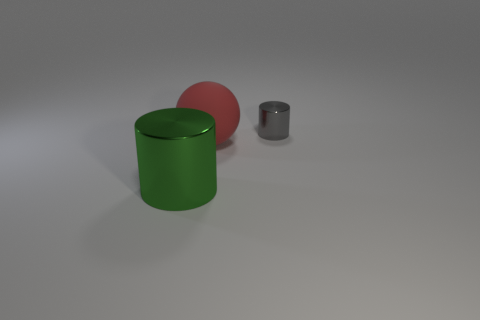Are there any other things that have the same material as the big red thing?
Provide a succinct answer. No. How many other objects are there of the same material as the small gray cylinder?
Give a very brief answer. 1. What number of things are yellow matte cubes or big spheres?
Ensure brevity in your answer.  1. Is the number of large balls that are behind the red rubber ball greater than the number of small gray objects that are on the left side of the tiny gray cylinder?
Keep it short and to the point. No. There is a metal thing that is on the right side of the big green metal thing; is it the same color as the cylinder that is in front of the large red ball?
Your answer should be very brief. No. How big is the shiny object that is right of the shiny object that is in front of the shiny object behind the big cylinder?
Provide a short and direct response. Small. The other big metallic object that is the same shape as the gray metallic thing is what color?
Keep it short and to the point. Green. Is the number of large green things in front of the large green metal cylinder greater than the number of tiny red rubber cubes?
Your response must be concise. No. There is a large shiny thing; is its shape the same as the big thing behind the green thing?
Provide a short and direct response. No. Is there any other thing that has the same size as the red sphere?
Provide a short and direct response. Yes. 